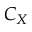<formula> <loc_0><loc_0><loc_500><loc_500>C _ { X }</formula> 